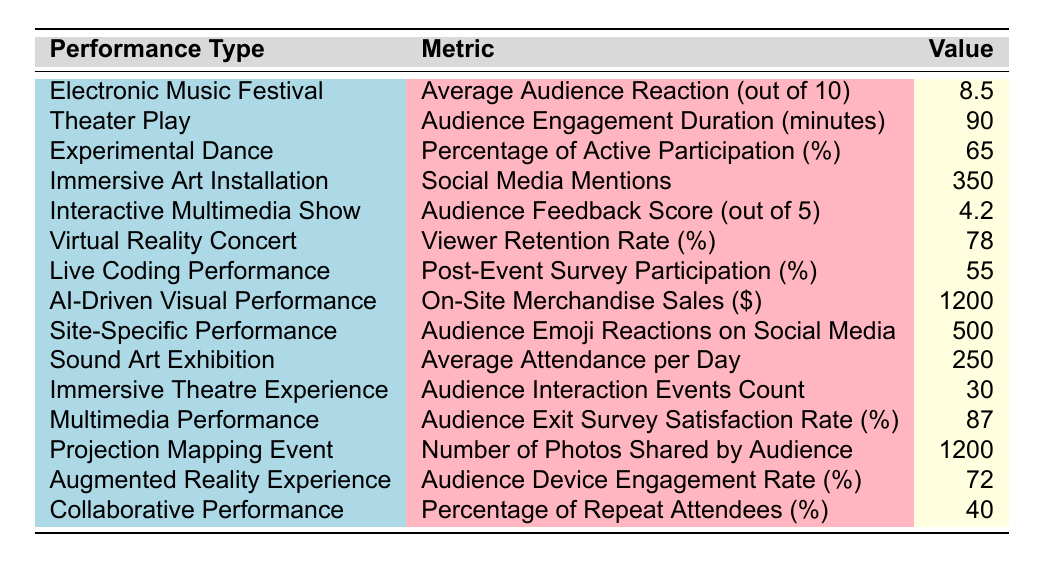What is the Average Audience Reaction for the Electronic Music Festival? According to the table, the Average Audience Reaction for the Electronic Music Festival is listed as 8.5.
Answer: 8.5 What is the Audience Engagement Duration for the Theater Play? The Audience Engagement Duration for the Theater Play is 90 minutes as specified in the table.
Answer: 90 Which performance type has the highest number of social media mentions? The Immersive Art Installation has the highest number of social media mentions with a value of 350.
Answer: Immersive Art Installation How many audience emoji reactions were received for the Site-Specific Performance? The Site-Specific Performance received 500 audience emoji reactions, as indicated in the table.
Answer: 500 What percentage of attendees participated in the post-event survey for the Live Coding Performance? The Live Coding Performance had a post-event survey participation rate of 55%.
Answer: 55 What is the difference between the Audience Feedback Score for the Interactive Multimedia Show and the Average Audience Reaction for the Electronic Music Festival? The Audience Feedback Score for the Interactive Multimedia Show is 4.2 (out of 5) and the Average Audience Reaction for the Electronic Music Festival is 8.5 (out of 10). The difference is calculated by converting the Interactive Multimedia Show score to a similar scale: (4.2/5) * 10 = 8.4. The difference is 8.5 - 8.4 = 0.1.
Answer: 0.1 Is the Viewer Retention Rate for the Virtual Reality Concert greater than 75%? Yes, the Viewer Retention Rate for the Virtual Reality Concert is 78%, which is greater than 75%.
Answer: Yes What is the average Average Audience Exit Survey Satisfaction Rate across the Interactive Multimedia Show and the Multimedia Performance? The Audience Exit Survey Satisfaction Rate for Multimedia Performance is 87%, and for Interactive Multimedia Show, it is 4.2 (out of 5) or (4.2/5) * 100 = 84%. The average is (87 + 84) / 2 = 85.5%.
Answer: 85.5 Which performance type has the lowest percentage of repeat attendees? The Collaborative Performance has the lowest percentage of repeat attendees at 40%.
Answer: Collaborative Performance 